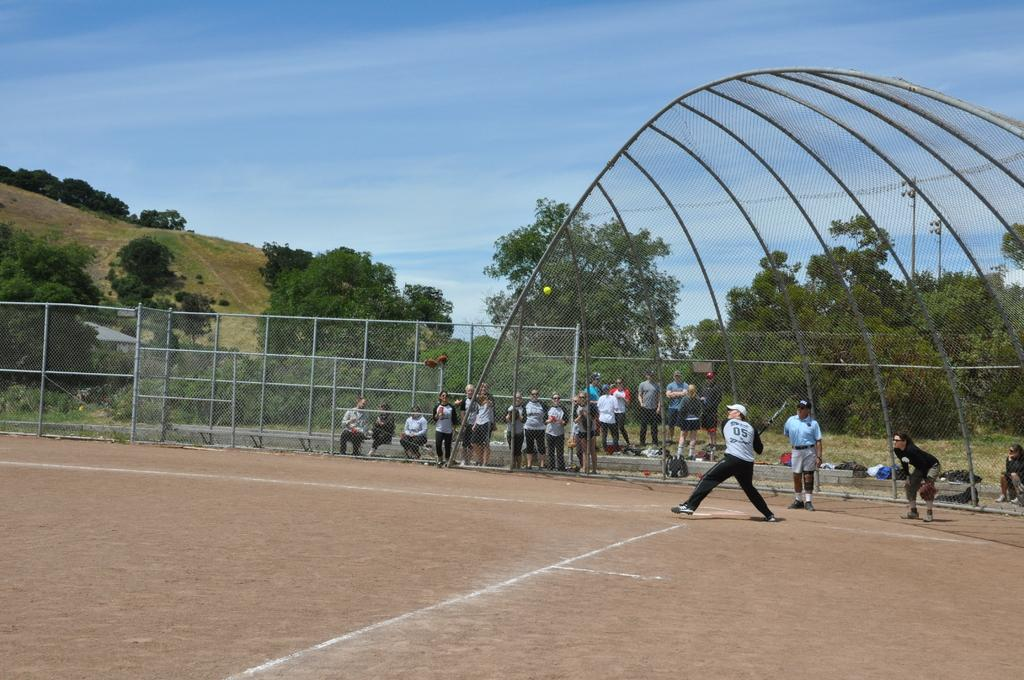<image>
Relay a brief, clear account of the picture shown. A baseball player with number 05 on the back of his shirt gets ready to bat. 